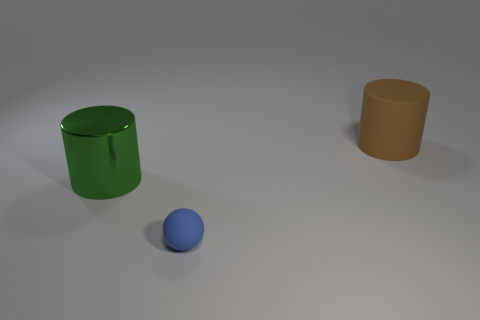Is the number of rubber things to the left of the large green metallic cylinder less than the number of big cyan metal objects? no 